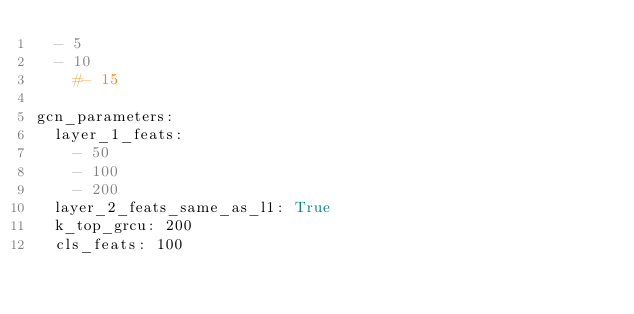Convert code to text. <code><loc_0><loc_0><loc_500><loc_500><_YAML_>  - 5
  - 10
    #- 15

gcn_parameters:
  layer_1_feats:
    - 50
    - 100
    - 200
  layer_2_feats_same_as_l1: True
  k_top_grcu: 200
  cls_feats: 100 
</code> 